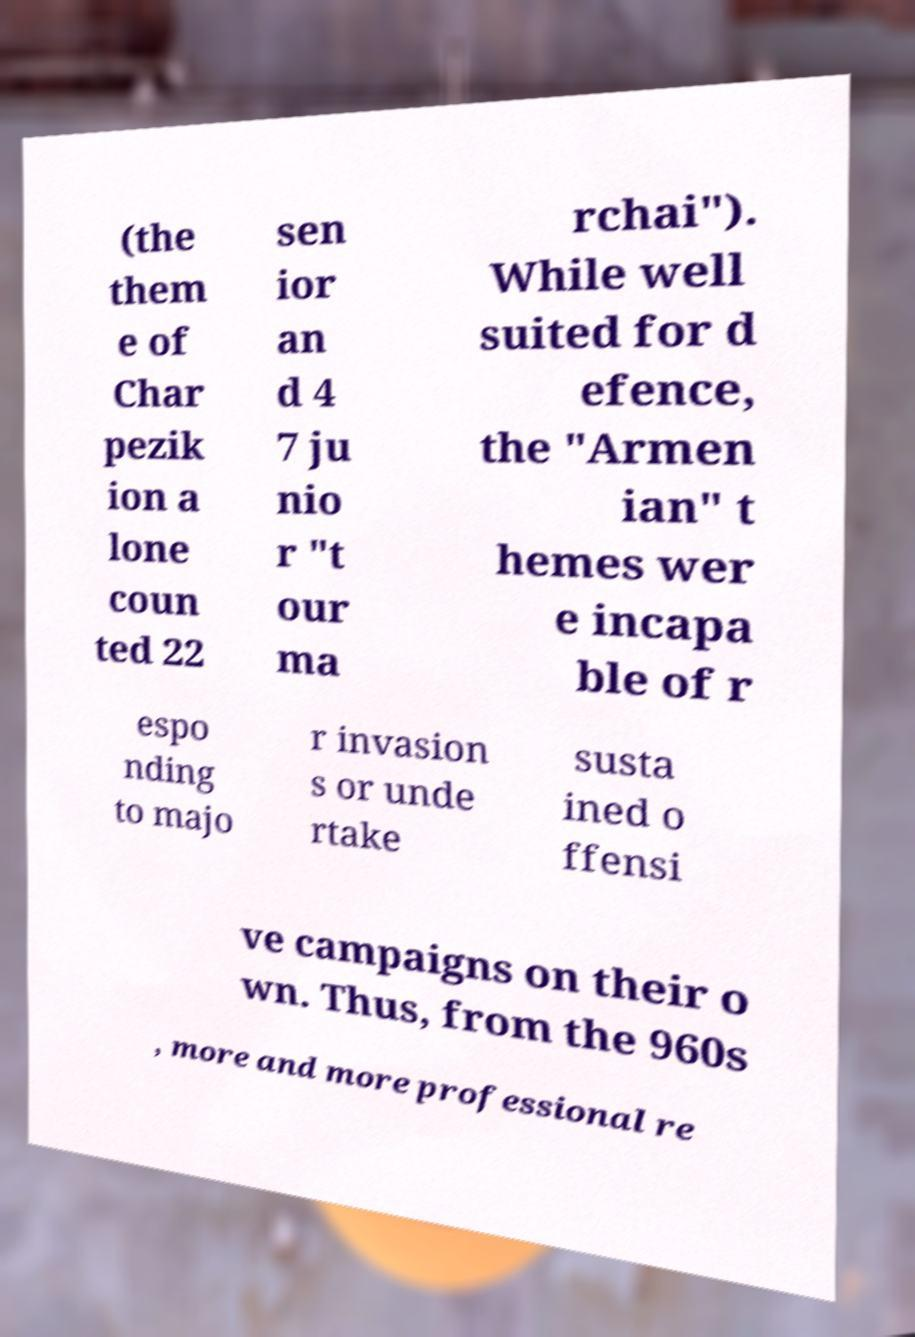Can you read and provide the text displayed in the image?This photo seems to have some interesting text. Can you extract and type it out for me? (the them e of Char pezik ion a lone coun ted 22 sen ior an d 4 7 ju nio r "t our ma rchai"). While well suited for d efence, the "Armen ian" t hemes wer e incapa ble of r espo nding to majo r invasion s or unde rtake susta ined o ffensi ve campaigns on their o wn. Thus, from the 960s , more and more professional re 